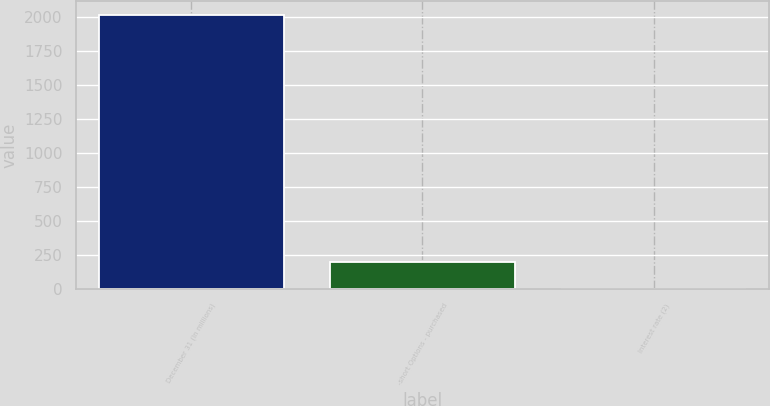Convert chart to OTSL. <chart><loc_0><loc_0><loc_500><loc_500><bar_chart><fcel>December 31 (In millions)<fcel>-short Options - purchased<fcel>Interest rate (2)<nl><fcel>2015<fcel>202.4<fcel>1<nl></chart> 